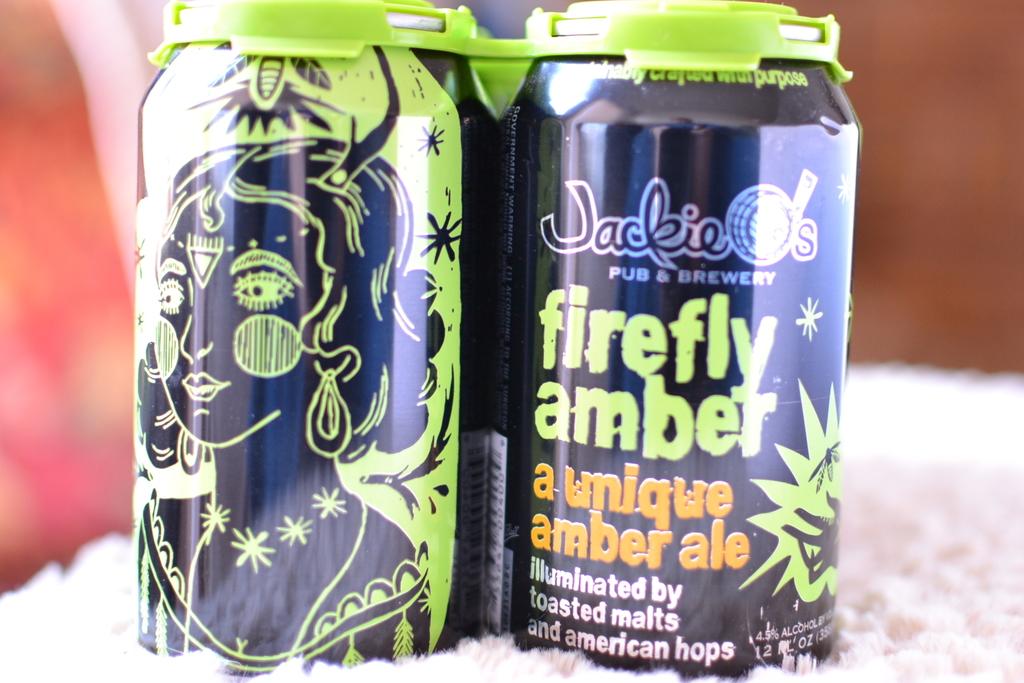What type of ale is this?
Your response must be concise. Amber. Who brewed this ale?
Offer a terse response. Jackie o's. 